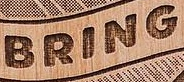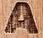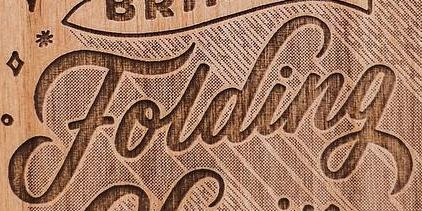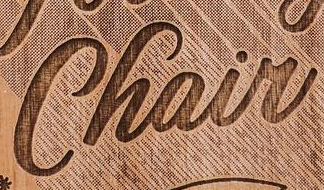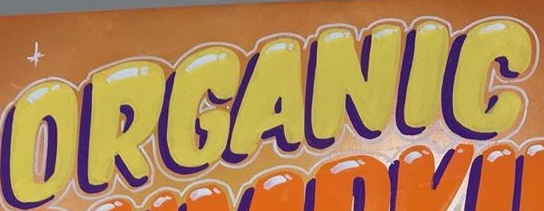Read the text content from these images in order, separated by a semicolon. BRING; A; Folding; Chair; ORGANIG 